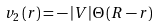Convert formula to latex. <formula><loc_0><loc_0><loc_500><loc_500>v _ { 2 } \left ( { r } \right ) = - \left | V \right | \Theta \left ( R - r \right )</formula> 